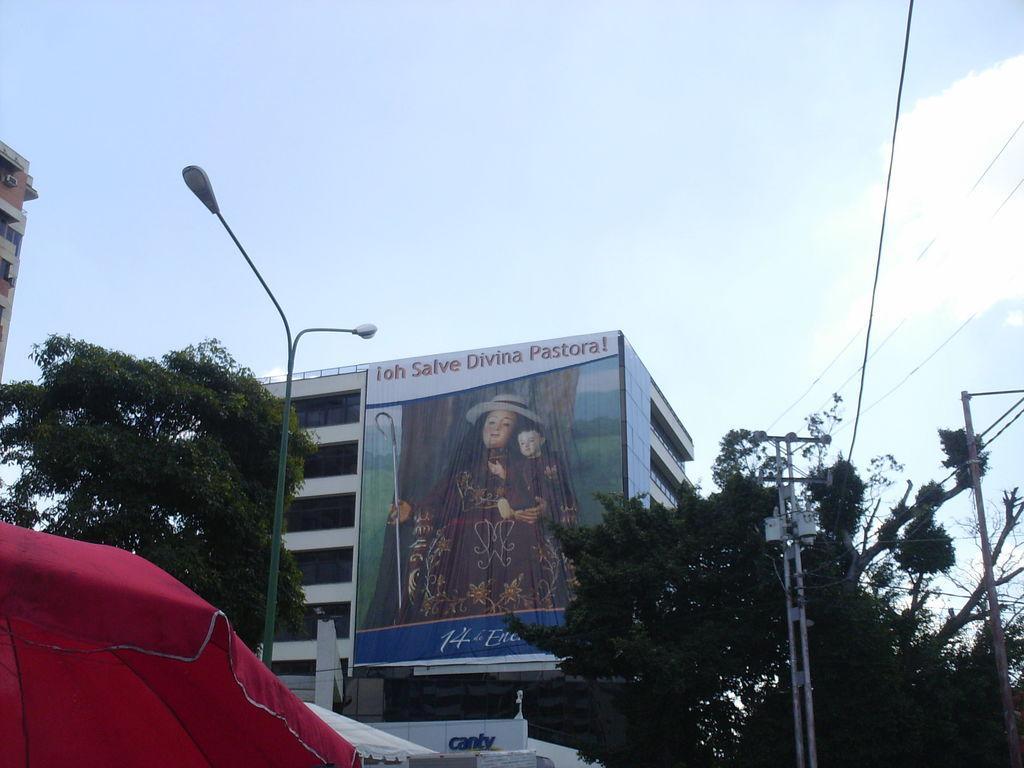How would you summarize this image in a sentence or two? In this image I can see light poles,trees and buildings. We can see a banner is attached to the building. I can see current pole and wires. The sky is white and blue color. In front I can see red color umbrella. 